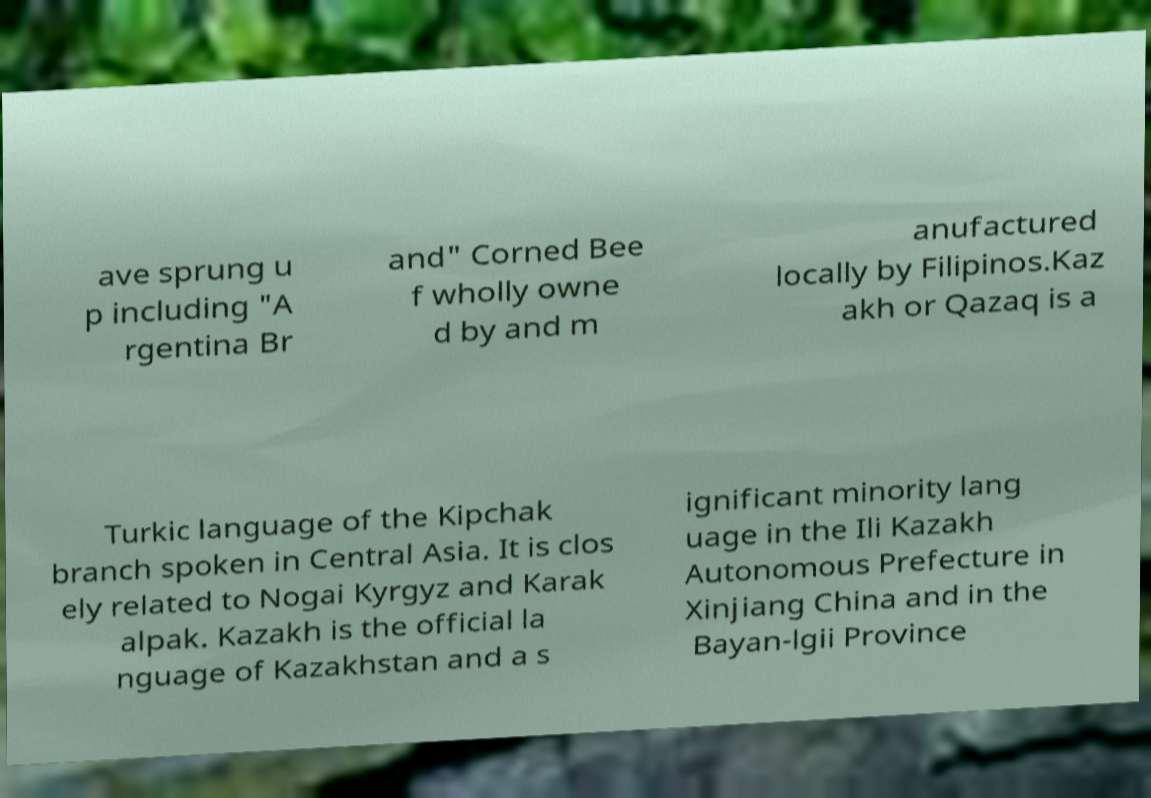Could you assist in decoding the text presented in this image and type it out clearly? ave sprung u p including "A rgentina Br and" Corned Bee f wholly owne d by and m anufactured locally by Filipinos.Kaz akh or Qazaq is a Turkic language of the Kipchak branch spoken in Central Asia. It is clos ely related to Nogai Kyrgyz and Karak alpak. Kazakh is the official la nguage of Kazakhstan and a s ignificant minority lang uage in the Ili Kazakh Autonomous Prefecture in Xinjiang China and in the Bayan-lgii Province 